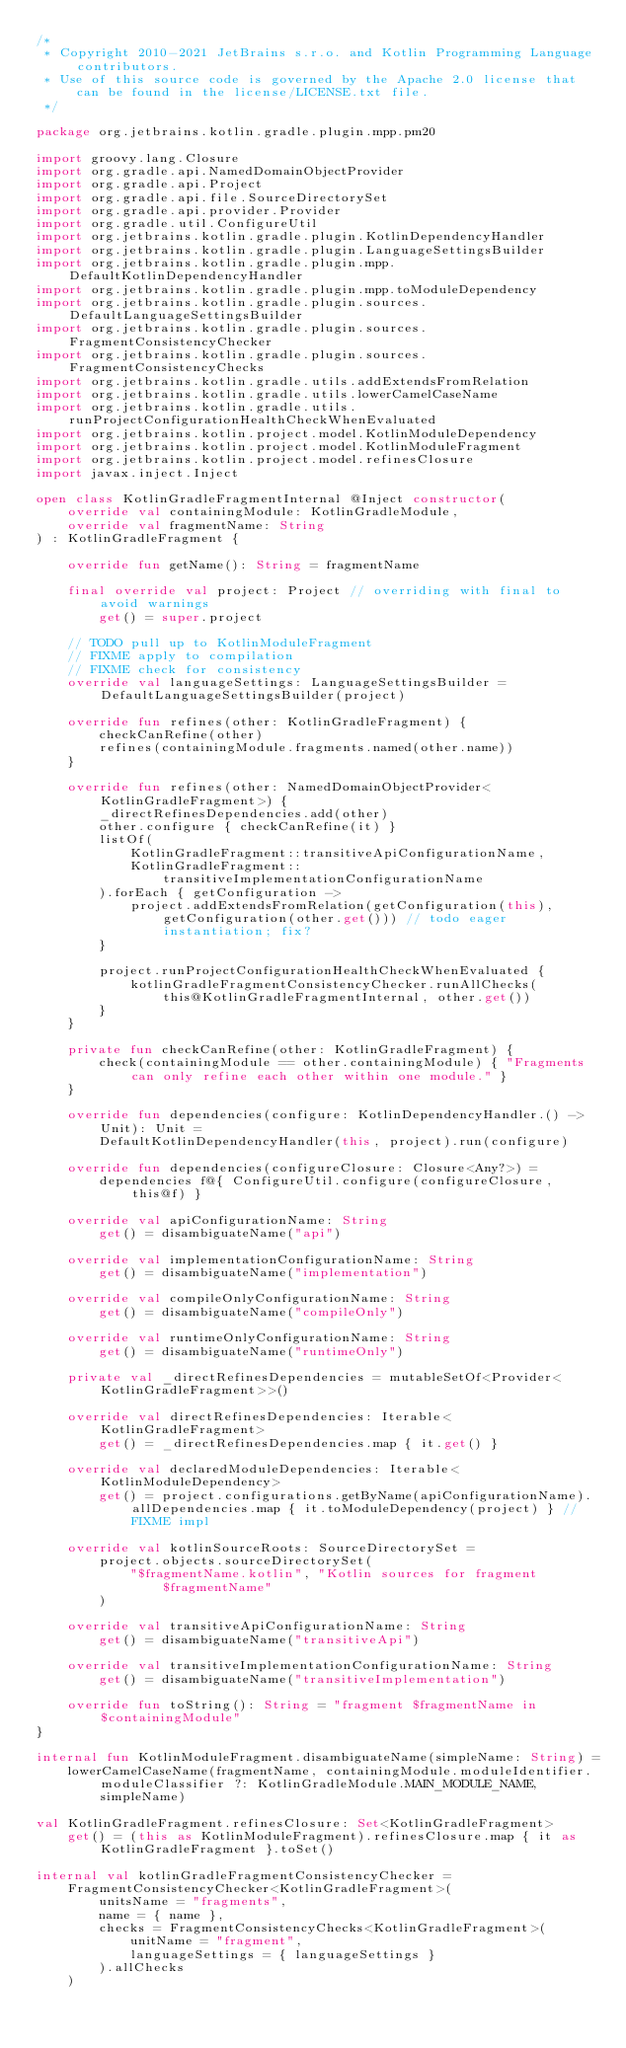<code> <loc_0><loc_0><loc_500><loc_500><_Kotlin_>/*
 * Copyright 2010-2021 JetBrains s.r.o. and Kotlin Programming Language contributors.
 * Use of this source code is governed by the Apache 2.0 license that can be found in the license/LICENSE.txt file.
 */

package org.jetbrains.kotlin.gradle.plugin.mpp.pm20

import groovy.lang.Closure
import org.gradle.api.NamedDomainObjectProvider
import org.gradle.api.Project
import org.gradle.api.file.SourceDirectorySet
import org.gradle.api.provider.Provider
import org.gradle.util.ConfigureUtil
import org.jetbrains.kotlin.gradle.plugin.KotlinDependencyHandler
import org.jetbrains.kotlin.gradle.plugin.LanguageSettingsBuilder
import org.jetbrains.kotlin.gradle.plugin.mpp.DefaultKotlinDependencyHandler
import org.jetbrains.kotlin.gradle.plugin.mpp.toModuleDependency
import org.jetbrains.kotlin.gradle.plugin.sources.DefaultLanguageSettingsBuilder
import org.jetbrains.kotlin.gradle.plugin.sources.FragmentConsistencyChecker
import org.jetbrains.kotlin.gradle.plugin.sources.FragmentConsistencyChecks
import org.jetbrains.kotlin.gradle.utils.addExtendsFromRelation
import org.jetbrains.kotlin.gradle.utils.lowerCamelCaseName
import org.jetbrains.kotlin.gradle.utils.runProjectConfigurationHealthCheckWhenEvaluated
import org.jetbrains.kotlin.project.model.KotlinModuleDependency
import org.jetbrains.kotlin.project.model.KotlinModuleFragment
import org.jetbrains.kotlin.project.model.refinesClosure
import javax.inject.Inject

open class KotlinGradleFragmentInternal @Inject constructor(
    override val containingModule: KotlinGradleModule,
    override val fragmentName: String
) : KotlinGradleFragment {

    override fun getName(): String = fragmentName

    final override val project: Project // overriding with final to avoid warnings
        get() = super.project

    // TODO pull up to KotlinModuleFragment
    // FIXME apply to compilation
    // FIXME check for consistency
    override val languageSettings: LanguageSettingsBuilder = DefaultLanguageSettingsBuilder(project)

    override fun refines(other: KotlinGradleFragment) {
        checkCanRefine(other)
        refines(containingModule.fragments.named(other.name))
    }

    override fun refines(other: NamedDomainObjectProvider<KotlinGradleFragment>) {
        _directRefinesDependencies.add(other)
        other.configure { checkCanRefine(it) }
        listOf(
            KotlinGradleFragment::transitiveApiConfigurationName,
            KotlinGradleFragment::transitiveImplementationConfigurationName
        ).forEach { getConfiguration ->
            project.addExtendsFromRelation(getConfiguration(this), getConfiguration(other.get())) // todo eager instantiation; fix?
        }

        project.runProjectConfigurationHealthCheckWhenEvaluated {
            kotlinGradleFragmentConsistencyChecker.runAllChecks(this@KotlinGradleFragmentInternal, other.get())
        }
    }

    private fun checkCanRefine(other: KotlinGradleFragment) {
        check(containingModule == other.containingModule) { "Fragments can only refine each other within one module." }
    }

    override fun dependencies(configure: KotlinDependencyHandler.() -> Unit): Unit =
        DefaultKotlinDependencyHandler(this, project).run(configure)

    override fun dependencies(configureClosure: Closure<Any?>) =
        dependencies f@{ ConfigureUtil.configure(configureClosure, this@f) }

    override val apiConfigurationName: String
        get() = disambiguateName("api")

    override val implementationConfigurationName: String
        get() = disambiguateName("implementation")

    override val compileOnlyConfigurationName: String
        get() = disambiguateName("compileOnly")

    override val runtimeOnlyConfigurationName: String
        get() = disambiguateName("runtimeOnly")

    private val _directRefinesDependencies = mutableSetOf<Provider<KotlinGradleFragment>>()

    override val directRefinesDependencies: Iterable<KotlinGradleFragment>
        get() = _directRefinesDependencies.map { it.get() }

    override val declaredModuleDependencies: Iterable<KotlinModuleDependency>
        get() = project.configurations.getByName(apiConfigurationName).allDependencies.map { it.toModuleDependency(project) } // FIXME impl

    override val kotlinSourceRoots: SourceDirectorySet =
        project.objects.sourceDirectorySet(
            "$fragmentName.kotlin", "Kotlin sources for fragment $fragmentName"
        )

    override val transitiveApiConfigurationName: String
        get() = disambiguateName("transitiveApi")

    override val transitiveImplementationConfigurationName: String
        get() = disambiguateName("transitiveImplementation")

    override fun toString(): String = "fragment $fragmentName in $containingModule"
}

internal fun KotlinModuleFragment.disambiguateName(simpleName: String) =
    lowerCamelCaseName(fragmentName, containingModule.moduleIdentifier.moduleClassifier ?: KotlinGradleModule.MAIN_MODULE_NAME, simpleName)

val KotlinGradleFragment.refinesClosure: Set<KotlinGradleFragment>
    get() = (this as KotlinModuleFragment).refinesClosure.map { it as KotlinGradleFragment }.toSet()

internal val kotlinGradleFragmentConsistencyChecker =
    FragmentConsistencyChecker<KotlinGradleFragment>(
        unitsName = "fragments",
        name = { name },
        checks = FragmentConsistencyChecks<KotlinGradleFragment>(
            unitName = "fragment",
            languageSettings = { languageSettings }
        ).allChecks
    )
</code> 